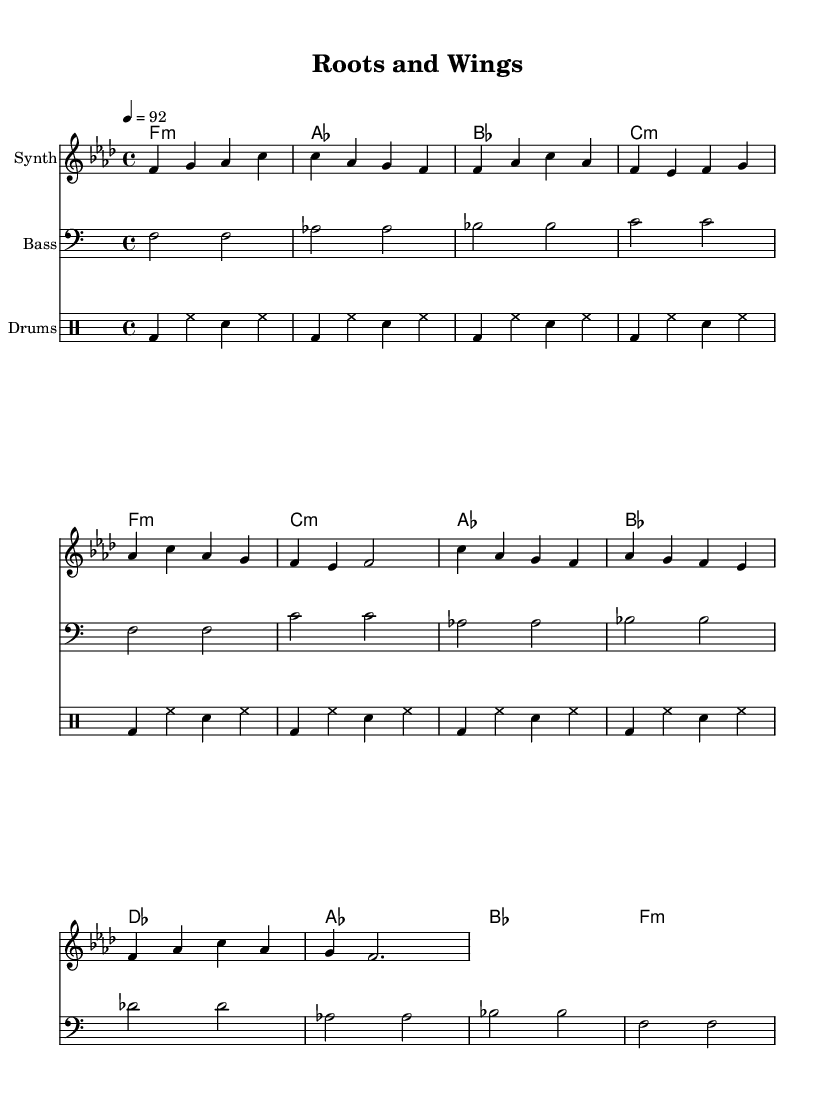What is the key signature of this music? The key signature is F minor, which is indicated by the presence of four flats in the signature (B♭, E♭, A♭, D♭) at the beginning of the staff.
Answer: F minor What is the time signature of the piece? The time signature is 4/4, which is indicated at the beginning of the score. This means there are four beats in each measure and the quarter note gets one beat.
Answer: 4/4 What is the tempo marking of the music? The tempo marking is 92, indicated by the tempo directive "4 = 92." This means that the quarter note should be played at a speed of 92 beats per minute.
Answer: 92 How many measures are in the chorus section? The chorus section has 4 measures, as this is determined by counting the number of measures specifically indicated under the "Chorus" label within the score.
Answer: 4 What type of staff is used for the rhythmic section? The rhythmic section utilizes a drum staff, as indicated by the "DrumStaff" label in the score. This specific staff is designed for notating percussion instruments.
Answer: Drum staff How many different chord types are used in the harmonies? The harmonies feature three different chord types: minor, major, and a diminished chord, as observed in the specified chord names like f:m, c:m, and others throughout the score.
Answer: Three What instruments are indicated in the score? The score indicates three instruments: Synth, Bass, and Drums, as identified by the "instrumentName" labels accompanying each part of the score.
Answer: Synth, Bass, and Drums 